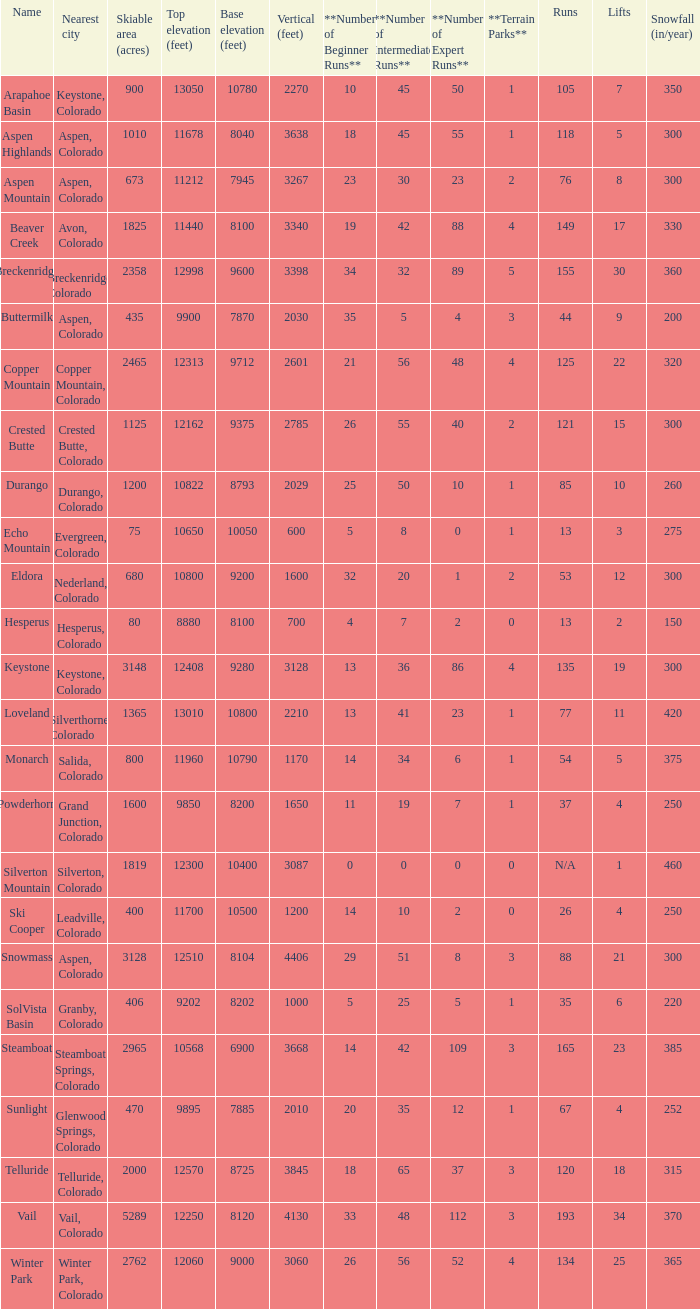If the name is Steamboat, what is the top elevation? 10568.0. 